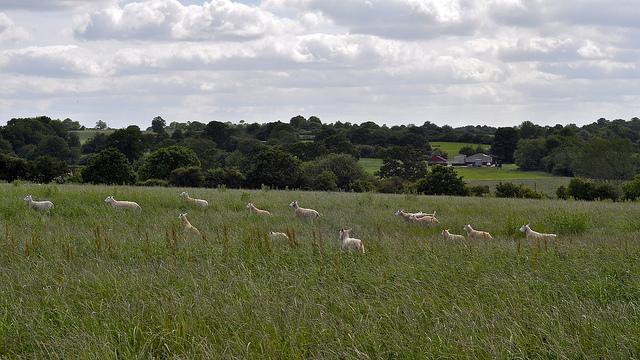How many animals can be seen?
Give a very brief answer. 13. How many animals are in this scene?
Give a very brief answer. 13. 